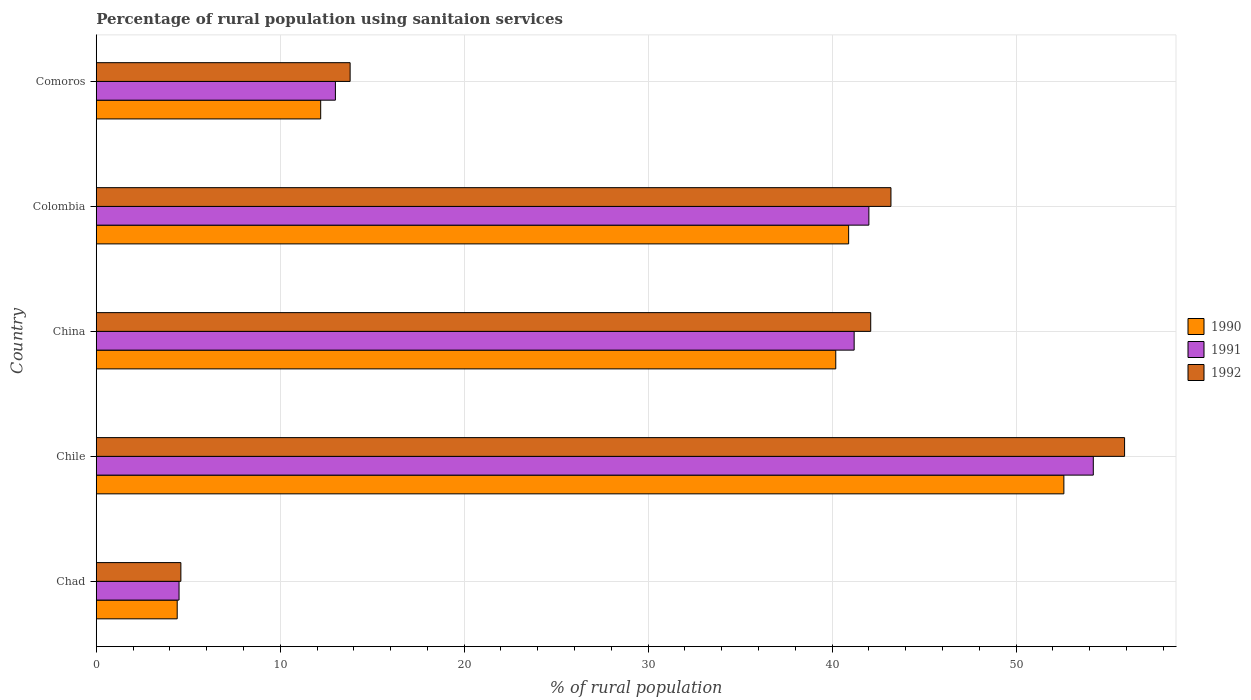How many different coloured bars are there?
Give a very brief answer. 3. Are the number of bars per tick equal to the number of legend labels?
Your response must be concise. Yes. How many bars are there on the 1st tick from the top?
Provide a short and direct response. 3. In how many cases, is the number of bars for a given country not equal to the number of legend labels?
Ensure brevity in your answer.  0. What is the percentage of rural population using sanitaion services in 1991 in Chad?
Ensure brevity in your answer.  4.5. Across all countries, what is the maximum percentage of rural population using sanitaion services in 1990?
Ensure brevity in your answer.  52.6. Across all countries, what is the minimum percentage of rural population using sanitaion services in 1992?
Offer a terse response. 4.6. In which country was the percentage of rural population using sanitaion services in 1991 minimum?
Provide a succinct answer. Chad. What is the total percentage of rural population using sanitaion services in 1991 in the graph?
Keep it short and to the point. 154.9. What is the difference between the percentage of rural population using sanitaion services in 1991 in China and the percentage of rural population using sanitaion services in 1992 in Chile?
Offer a very short reply. -14.7. What is the average percentage of rural population using sanitaion services in 1991 per country?
Provide a short and direct response. 30.98. What is the difference between the percentage of rural population using sanitaion services in 1992 and percentage of rural population using sanitaion services in 1991 in Chad?
Ensure brevity in your answer.  0.1. What is the ratio of the percentage of rural population using sanitaion services in 1990 in Chad to that in Comoros?
Your answer should be compact. 0.36. Is the percentage of rural population using sanitaion services in 1990 in China less than that in Colombia?
Your answer should be compact. Yes. Is the difference between the percentage of rural population using sanitaion services in 1992 in Chad and Chile greater than the difference between the percentage of rural population using sanitaion services in 1991 in Chad and Chile?
Make the answer very short. No. What is the difference between the highest and the second highest percentage of rural population using sanitaion services in 1991?
Offer a very short reply. 12.2. What is the difference between the highest and the lowest percentage of rural population using sanitaion services in 1990?
Your answer should be very brief. 48.2. Is it the case that in every country, the sum of the percentage of rural population using sanitaion services in 1990 and percentage of rural population using sanitaion services in 1991 is greater than the percentage of rural population using sanitaion services in 1992?
Your answer should be very brief. Yes. Are the values on the major ticks of X-axis written in scientific E-notation?
Your answer should be compact. No. Does the graph contain any zero values?
Provide a succinct answer. No. Does the graph contain grids?
Your answer should be very brief. Yes. Where does the legend appear in the graph?
Your answer should be compact. Center right. How many legend labels are there?
Give a very brief answer. 3. What is the title of the graph?
Keep it short and to the point. Percentage of rural population using sanitaion services. Does "1971" appear as one of the legend labels in the graph?
Provide a short and direct response. No. What is the label or title of the X-axis?
Keep it short and to the point. % of rural population. What is the % of rural population of 1991 in Chad?
Offer a very short reply. 4.5. What is the % of rural population in 1990 in Chile?
Offer a very short reply. 52.6. What is the % of rural population in 1991 in Chile?
Your answer should be very brief. 54.2. What is the % of rural population in 1992 in Chile?
Your answer should be compact. 55.9. What is the % of rural population of 1990 in China?
Offer a very short reply. 40.2. What is the % of rural population of 1991 in China?
Make the answer very short. 41.2. What is the % of rural population in 1992 in China?
Offer a terse response. 42.1. What is the % of rural population of 1990 in Colombia?
Your answer should be very brief. 40.9. What is the % of rural population of 1991 in Colombia?
Keep it short and to the point. 42. What is the % of rural population of 1992 in Colombia?
Provide a succinct answer. 43.2. What is the % of rural population in 1990 in Comoros?
Keep it short and to the point. 12.2. What is the % of rural population in 1992 in Comoros?
Offer a very short reply. 13.8. Across all countries, what is the maximum % of rural population of 1990?
Your answer should be very brief. 52.6. Across all countries, what is the maximum % of rural population in 1991?
Offer a terse response. 54.2. Across all countries, what is the maximum % of rural population in 1992?
Give a very brief answer. 55.9. Across all countries, what is the minimum % of rural population in 1990?
Give a very brief answer. 4.4. What is the total % of rural population of 1990 in the graph?
Offer a very short reply. 150.3. What is the total % of rural population of 1991 in the graph?
Give a very brief answer. 154.9. What is the total % of rural population in 1992 in the graph?
Offer a terse response. 159.6. What is the difference between the % of rural population of 1990 in Chad and that in Chile?
Your response must be concise. -48.2. What is the difference between the % of rural population of 1991 in Chad and that in Chile?
Provide a short and direct response. -49.7. What is the difference between the % of rural population in 1992 in Chad and that in Chile?
Provide a short and direct response. -51.3. What is the difference between the % of rural population in 1990 in Chad and that in China?
Provide a succinct answer. -35.8. What is the difference between the % of rural population in 1991 in Chad and that in China?
Offer a terse response. -36.7. What is the difference between the % of rural population of 1992 in Chad and that in China?
Your answer should be very brief. -37.5. What is the difference between the % of rural population in 1990 in Chad and that in Colombia?
Your answer should be compact. -36.5. What is the difference between the % of rural population in 1991 in Chad and that in Colombia?
Provide a short and direct response. -37.5. What is the difference between the % of rural population in 1992 in Chad and that in Colombia?
Your response must be concise. -38.6. What is the difference between the % of rural population in 1990 in Chile and that in China?
Ensure brevity in your answer.  12.4. What is the difference between the % of rural population in 1991 in Chile and that in China?
Your answer should be compact. 13. What is the difference between the % of rural population in 1992 in Chile and that in Colombia?
Keep it short and to the point. 12.7. What is the difference between the % of rural population in 1990 in Chile and that in Comoros?
Provide a succinct answer. 40.4. What is the difference between the % of rural population of 1991 in Chile and that in Comoros?
Your answer should be compact. 41.2. What is the difference between the % of rural population of 1992 in Chile and that in Comoros?
Provide a succinct answer. 42.1. What is the difference between the % of rural population of 1991 in China and that in Comoros?
Your answer should be very brief. 28.2. What is the difference between the % of rural population in 1992 in China and that in Comoros?
Offer a terse response. 28.3. What is the difference between the % of rural population in 1990 in Colombia and that in Comoros?
Ensure brevity in your answer.  28.7. What is the difference between the % of rural population in 1991 in Colombia and that in Comoros?
Offer a terse response. 29. What is the difference between the % of rural population in 1992 in Colombia and that in Comoros?
Give a very brief answer. 29.4. What is the difference between the % of rural population of 1990 in Chad and the % of rural population of 1991 in Chile?
Ensure brevity in your answer.  -49.8. What is the difference between the % of rural population in 1990 in Chad and the % of rural population in 1992 in Chile?
Provide a succinct answer. -51.5. What is the difference between the % of rural population of 1991 in Chad and the % of rural population of 1992 in Chile?
Your response must be concise. -51.4. What is the difference between the % of rural population of 1990 in Chad and the % of rural population of 1991 in China?
Your answer should be compact. -36.8. What is the difference between the % of rural population in 1990 in Chad and the % of rural population in 1992 in China?
Give a very brief answer. -37.7. What is the difference between the % of rural population in 1991 in Chad and the % of rural population in 1992 in China?
Provide a short and direct response. -37.6. What is the difference between the % of rural population of 1990 in Chad and the % of rural population of 1991 in Colombia?
Offer a very short reply. -37.6. What is the difference between the % of rural population of 1990 in Chad and the % of rural population of 1992 in Colombia?
Provide a succinct answer. -38.8. What is the difference between the % of rural population in 1991 in Chad and the % of rural population in 1992 in Colombia?
Offer a very short reply. -38.7. What is the difference between the % of rural population in 1990 in Chad and the % of rural population in 1991 in Comoros?
Offer a terse response. -8.6. What is the difference between the % of rural population in 1990 in Chad and the % of rural population in 1992 in Comoros?
Your answer should be compact. -9.4. What is the difference between the % of rural population of 1991 in Chad and the % of rural population of 1992 in Comoros?
Your response must be concise. -9.3. What is the difference between the % of rural population of 1990 in Chile and the % of rural population of 1992 in China?
Provide a succinct answer. 10.5. What is the difference between the % of rural population of 1990 in Chile and the % of rural population of 1991 in Colombia?
Offer a terse response. 10.6. What is the difference between the % of rural population of 1990 in Chile and the % of rural population of 1991 in Comoros?
Offer a terse response. 39.6. What is the difference between the % of rural population in 1990 in Chile and the % of rural population in 1992 in Comoros?
Provide a short and direct response. 38.8. What is the difference between the % of rural population of 1991 in Chile and the % of rural population of 1992 in Comoros?
Make the answer very short. 40.4. What is the difference between the % of rural population in 1990 in China and the % of rural population in 1991 in Comoros?
Give a very brief answer. 27.2. What is the difference between the % of rural population of 1990 in China and the % of rural population of 1992 in Comoros?
Offer a very short reply. 26.4. What is the difference between the % of rural population of 1991 in China and the % of rural population of 1992 in Comoros?
Give a very brief answer. 27.4. What is the difference between the % of rural population of 1990 in Colombia and the % of rural population of 1991 in Comoros?
Keep it short and to the point. 27.9. What is the difference between the % of rural population in 1990 in Colombia and the % of rural population in 1992 in Comoros?
Keep it short and to the point. 27.1. What is the difference between the % of rural population of 1991 in Colombia and the % of rural population of 1992 in Comoros?
Give a very brief answer. 28.2. What is the average % of rural population in 1990 per country?
Offer a terse response. 30.06. What is the average % of rural population of 1991 per country?
Offer a very short reply. 30.98. What is the average % of rural population of 1992 per country?
Keep it short and to the point. 31.92. What is the difference between the % of rural population in 1990 and % of rural population in 1992 in Chad?
Your answer should be very brief. -0.2. What is the difference between the % of rural population in 1990 and % of rural population in 1991 in Chile?
Ensure brevity in your answer.  -1.6. What is the difference between the % of rural population in 1991 and % of rural population in 1992 in Chile?
Ensure brevity in your answer.  -1.7. What is the difference between the % of rural population in 1990 and % of rural population in 1991 in China?
Offer a terse response. -1. What is the difference between the % of rural population in 1990 and % of rural population in 1992 in China?
Ensure brevity in your answer.  -1.9. What is the difference between the % of rural population of 1991 and % of rural population of 1992 in Comoros?
Give a very brief answer. -0.8. What is the ratio of the % of rural population in 1990 in Chad to that in Chile?
Offer a very short reply. 0.08. What is the ratio of the % of rural population in 1991 in Chad to that in Chile?
Keep it short and to the point. 0.08. What is the ratio of the % of rural population of 1992 in Chad to that in Chile?
Your response must be concise. 0.08. What is the ratio of the % of rural population in 1990 in Chad to that in China?
Ensure brevity in your answer.  0.11. What is the ratio of the % of rural population in 1991 in Chad to that in China?
Offer a very short reply. 0.11. What is the ratio of the % of rural population of 1992 in Chad to that in China?
Your response must be concise. 0.11. What is the ratio of the % of rural population in 1990 in Chad to that in Colombia?
Make the answer very short. 0.11. What is the ratio of the % of rural population in 1991 in Chad to that in Colombia?
Keep it short and to the point. 0.11. What is the ratio of the % of rural population in 1992 in Chad to that in Colombia?
Offer a very short reply. 0.11. What is the ratio of the % of rural population in 1990 in Chad to that in Comoros?
Your answer should be very brief. 0.36. What is the ratio of the % of rural population of 1991 in Chad to that in Comoros?
Provide a succinct answer. 0.35. What is the ratio of the % of rural population of 1990 in Chile to that in China?
Give a very brief answer. 1.31. What is the ratio of the % of rural population of 1991 in Chile to that in China?
Your answer should be very brief. 1.32. What is the ratio of the % of rural population of 1992 in Chile to that in China?
Provide a succinct answer. 1.33. What is the ratio of the % of rural population in 1990 in Chile to that in Colombia?
Give a very brief answer. 1.29. What is the ratio of the % of rural population of 1991 in Chile to that in Colombia?
Provide a succinct answer. 1.29. What is the ratio of the % of rural population of 1992 in Chile to that in Colombia?
Give a very brief answer. 1.29. What is the ratio of the % of rural population of 1990 in Chile to that in Comoros?
Provide a short and direct response. 4.31. What is the ratio of the % of rural population of 1991 in Chile to that in Comoros?
Offer a very short reply. 4.17. What is the ratio of the % of rural population of 1992 in Chile to that in Comoros?
Provide a succinct answer. 4.05. What is the ratio of the % of rural population of 1990 in China to that in Colombia?
Give a very brief answer. 0.98. What is the ratio of the % of rural population in 1991 in China to that in Colombia?
Offer a very short reply. 0.98. What is the ratio of the % of rural population in 1992 in China to that in Colombia?
Give a very brief answer. 0.97. What is the ratio of the % of rural population in 1990 in China to that in Comoros?
Ensure brevity in your answer.  3.3. What is the ratio of the % of rural population in 1991 in China to that in Comoros?
Offer a very short reply. 3.17. What is the ratio of the % of rural population of 1992 in China to that in Comoros?
Offer a terse response. 3.05. What is the ratio of the % of rural population of 1990 in Colombia to that in Comoros?
Your response must be concise. 3.35. What is the ratio of the % of rural population in 1991 in Colombia to that in Comoros?
Give a very brief answer. 3.23. What is the ratio of the % of rural population in 1992 in Colombia to that in Comoros?
Your answer should be compact. 3.13. What is the difference between the highest and the lowest % of rural population of 1990?
Your answer should be very brief. 48.2. What is the difference between the highest and the lowest % of rural population of 1991?
Keep it short and to the point. 49.7. What is the difference between the highest and the lowest % of rural population in 1992?
Make the answer very short. 51.3. 